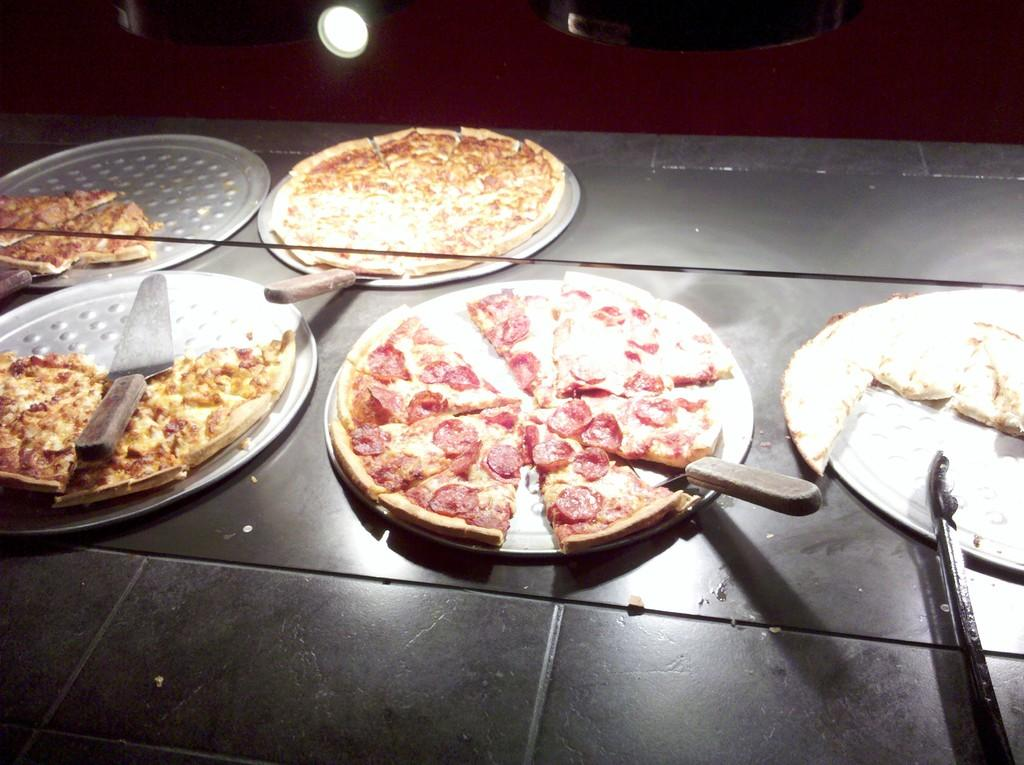What type of food can be seen in the image? There are pizzas in the image. What utensil is present in the image? There is a knife in the image. What cooking equipment can be seen in the image? There are pans in the image. Where are the objects placed in the image? The objects are placed on a table. What can be seen in the background of the image? There is light in the background of the image. What type of badge is visible on the pizza in the image? There is no badge present on the pizza in the image. What type of tail can be seen on the knife in the image? There is no tail present on the knife in the image. 